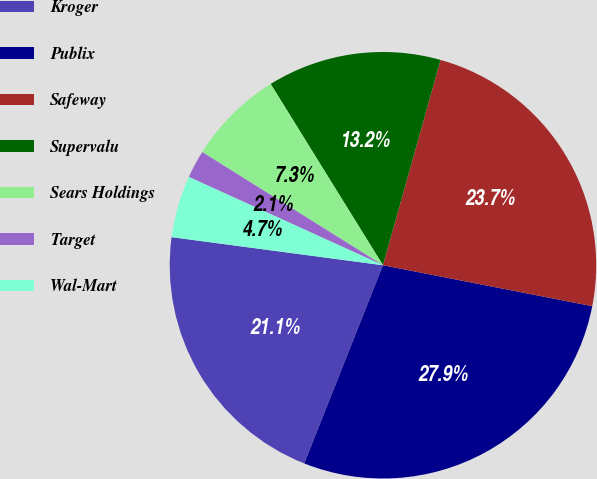Convert chart to OTSL. <chart><loc_0><loc_0><loc_500><loc_500><pie_chart><fcel>Kroger<fcel>Publix<fcel>Safeway<fcel>Supervalu<fcel>Sears Holdings<fcel>Target<fcel>Wal-Mart<nl><fcel>21.09%<fcel>27.94%<fcel>23.72%<fcel>13.18%<fcel>7.27%<fcel>2.11%<fcel>4.69%<nl></chart> 